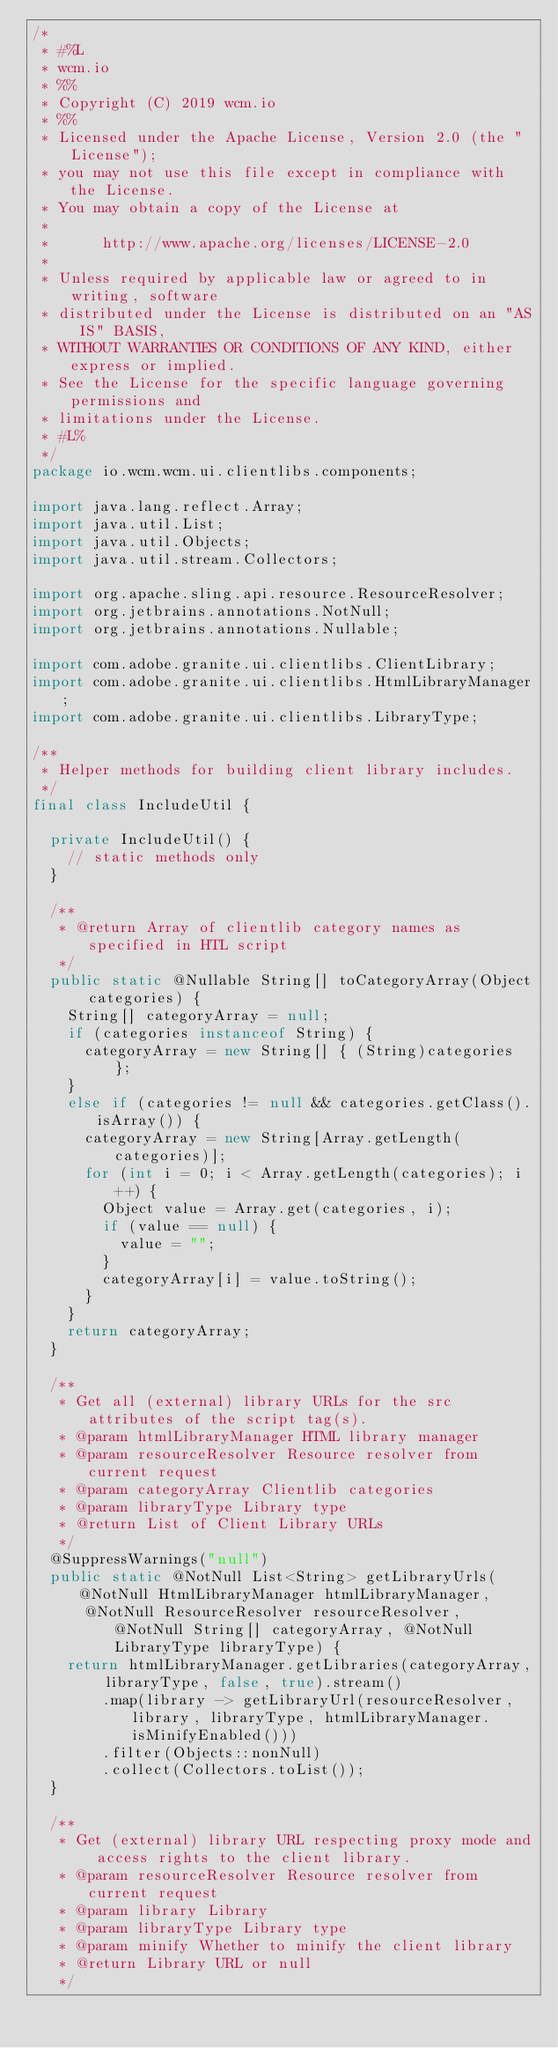<code> <loc_0><loc_0><loc_500><loc_500><_Java_>/*
 * #%L
 * wcm.io
 * %%
 * Copyright (C) 2019 wcm.io
 * %%
 * Licensed under the Apache License, Version 2.0 (the "License");
 * you may not use this file except in compliance with the License.
 * You may obtain a copy of the License at
 *
 *      http://www.apache.org/licenses/LICENSE-2.0
 *
 * Unless required by applicable law or agreed to in writing, software
 * distributed under the License is distributed on an "AS IS" BASIS,
 * WITHOUT WARRANTIES OR CONDITIONS OF ANY KIND, either express or implied.
 * See the License for the specific language governing permissions and
 * limitations under the License.
 * #L%
 */
package io.wcm.wcm.ui.clientlibs.components;

import java.lang.reflect.Array;
import java.util.List;
import java.util.Objects;
import java.util.stream.Collectors;

import org.apache.sling.api.resource.ResourceResolver;
import org.jetbrains.annotations.NotNull;
import org.jetbrains.annotations.Nullable;

import com.adobe.granite.ui.clientlibs.ClientLibrary;
import com.adobe.granite.ui.clientlibs.HtmlLibraryManager;
import com.adobe.granite.ui.clientlibs.LibraryType;

/**
 * Helper methods for building client library includes.
 */
final class IncludeUtil {

  private IncludeUtil() {
    // static methods only
  }

  /**
   * @return Array of clientlib category names as specified in HTL script
   */
  public static @Nullable String[] toCategoryArray(Object categories) {
    String[] categoryArray = null;
    if (categories instanceof String) {
      categoryArray = new String[] { (String)categories };
    }
    else if (categories != null && categories.getClass().isArray()) {
      categoryArray = new String[Array.getLength(categories)];
      for (int i = 0; i < Array.getLength(categories); i++) {
        Object value = Array.get(categories, i);
        if (value == null) {
          value = "";
        }
        categoryArray[i] = value.toString();
      }
    }
    return categoryArray;
  }

  /**
   * Get all (external) library URLs for the src attributes of the script tag(s).
   * @param htmlLibraryManager HTML library manager
   * @param resourceResolver Resource resolver from current request
   * @param categoryArray Clientlib categories
   * @param libraryType Library type
   * @return List of Client Library URLs
   */
  @SuppressWarnings("null")
  public static @NotNull List<String> getLibraryUrls(@NotNull HtmlLibraryManager htmlLibraryManager,
      @NotNull ResourceResolver resourceResolver, @NotNull String[] categoryArray, @NotNull LibraryType libraryType) {
    return htmlLibraryManager.getLibraries(categoryArray, libraryType, false, true).stream()
        .map(library -> getLibraryUrl(resourceResolver, library, libraryType, htmlLibraryManager.isMinifyEnabled()))
        .filter(Objects::nonNull)
        .collect(Collectors.toList());
  }

  /**
   * Get (external) library URL respecting proxy mode and access rights to the client library.
   * @param resourceResolver Resource resolver from current request
   * @param library Library
   * @param libraryType Library type
   * @param minify Whether to minify the client library
   * @return Library URL or null
   */</code> 